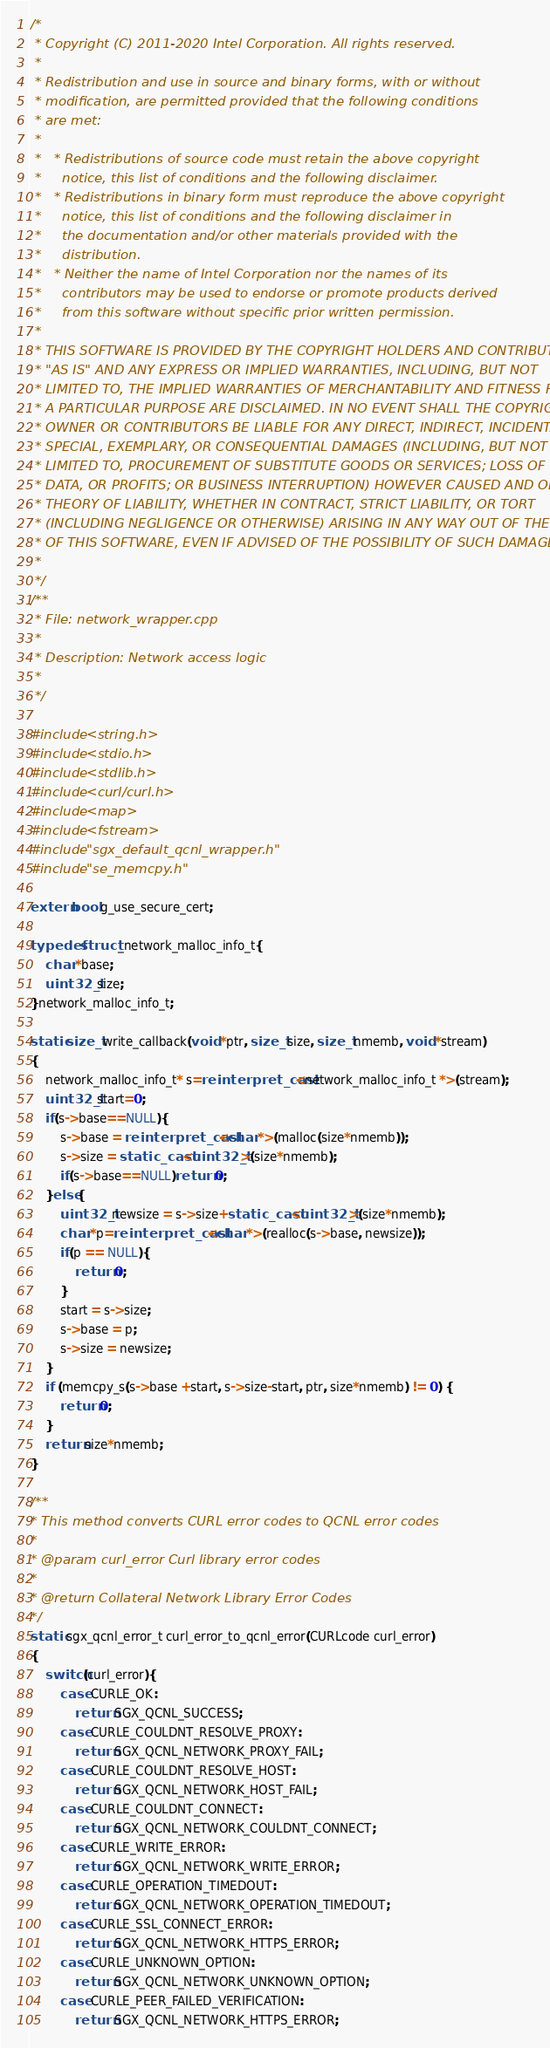<code> <loc_0><loc_0><loc_500><loc_500><_C++_>/*
 * Copyright (C) 2011-2020 Intel Corporation. All rights reserved.
 *
 * Redistribution and use in source and binary forms, with or without
 * modification, are permitted provided that the following conditions
 * are met:
 *
 *   * Redistributions of source code must retain the above copyright
 *     notice, this list of conditions and the following disclaimer.
 *   * Redistributions in binary form must reproduce the above copyright
 *     notice, this list of conditions and the following disclaimer in
 *     the documentation and/or other materials provided with the
 *     distribution.
 *   * Neither the name of Intel Corporation nor the names of its
 *     contributors may be used to endorse or promote products derived
 *     from this software without specific prior written permission.
 *
 * THIS SOFTWARE IS PROVIDED BY THE COPYRIGHT HOLDERS AND CONTRIBUTORS
 * "AS IS" AND ANY EXPRESS OR IMPLIED WARRANTIES, INCLUDING, BUT NOT
 * LIMITED TO, THE IMPLIED WARRANTIES OF MERCHANTABILITY AND FITNESS FOR
 * A PARTICULAR PURPOSE ARE DISCLAIMED. IN NO EVENT SHALL THE COPYRIGHT
 * OWNER OR CONTRIBUTORS BE LIABLE FOR ANY DIRECT, INDIRECT, INCIDENTAL,
 * SPECIAL, EXEMPLARY, OR CONSEQUENTIAL DAMAGES (INCLUDING, BUT NOT
 * LIMITED TO, PROCUREMENT OF SUBSTITUTE GOODS OR SERVICES; LOSS OF USE,
 * DATA, OR PROFITS; OR BUSINESS INTERRUPTION) HOWEVER CAUSED AND ON ANY
 * THEORY OF LIABILITY, WHETHER IN CONTRACT, STRICT LIABILITY, OR TORT
 * (INCLUDING NEGLIGENCE OR OTHERWISE) ARISING IN ANY WAY OUT OF THE USE
 * OF THIS SOFTWARE, EVEN IF ADVISED OF THE POSSIBILITY OF SUCH DAMAGE.
 *
 */
/**
 * File: network_wrapper.cpp
 *  
 * Description: Network access logic
 *
 */

#include <string.h>
#include <stdio.h>
#include <stdlib.h>
#include <curl/curl.h>
#include <map>
#include <fstream>
#include "sgx_default_qcnl_wrapper.h"
#include "se_memcpy.h"

extern bool g_use_secure_cert;

typedef struct _network_malloc_info_t{
    char *base;
    uint32_t size;
}network_malloc_info_t;

static size_t write_callback(void *ptr, size_t size, size_t nmemb, void *stream)
{
    network_malloc_info_t* s=reinterpret_cast<network_malloc_info_t *>(stream);
    uint32_t start=0;
    if(s->base==NULL){
        s->base = reinterpret_cast<char *>(malloc(size*nmemb));
        s->size = static_cast<uint32_t>(size*nmemb);
        if(s->base==NULL)return 0;
    }else{
        uint32_t newsize = s->size+static_cast<uint32_t>(size*nmemb);
        char *p=reinterpret_cast<char *>(realloc(s->base, newsize));
        if(p == NULL){
            return 0;
        }
        start = s->size;
        s->base = p;
        s->size = newsize;
    }
    if (memcpy_s(s->base +start, s->size-start, ptr, size*nmemb) != 0) {
        return 0;
    }
    return size*nmemb;
}

/**
* This method converts CURL error codes to QCNL error codes
*
* @param curl_error Curl library error codes
*
* @return Collateral Network Library Error Codes
*/
static sgx_qcnl_error_t curl_error_to_qcnl_error(CURLcode curl_error)
{
    switch(curl_error){
        case CURLE_OK:
            return SGX_QCNL_SUCCESS;
        case CURLE_COULDNT_RESOLVE_PROXY:
            return SGX_QCNL_NETWORK_PROXY_FAIL;
        case CURLE_COULDNT_RESOLVE_HOST:
            return SGX_QCNL_NETWORK_HOST_FAIL;
        case CURLE_COULDNT_CONNECT:
            return SGX_QCNL_NETWORK_COULDNT_CONNECT;
        case CURLE_WRITE_ERROR:
            return SGX_QCNL_NETWORK_WRITE_ERROR;
        case CURLE_OPERATION_TIMEDOUT:
            return SGX_QCNL_NETWORK_OPERATION_TIMEDOUT;
        case CURLE_SSL_CONNECT_ERROR:
            return SGX_QCNL_NETWORK_HTTPS_ERROR;
        case CURLE_UNKNOWN_OPTION:
            return SGX_QCNL_NETWORK_UNKNOWN_OPTION;
        case CURLE_PEER_FAILED_VERIFICATION:
            return SGX_QCNL_NETWORK_HTTPS_ERROR;</code> 